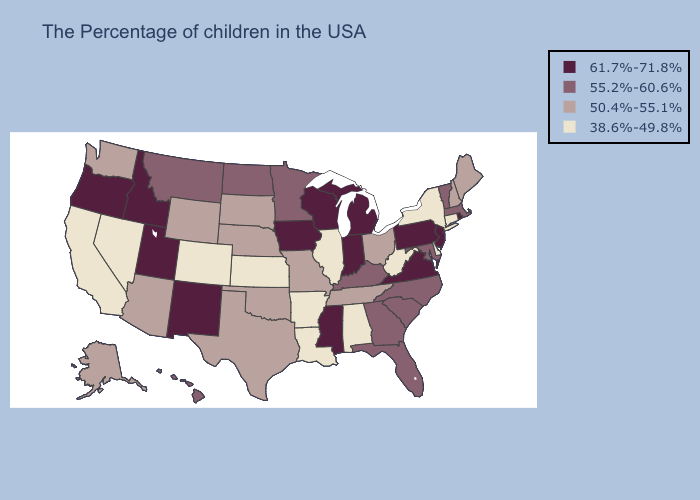Does the first symbol in the legend represent the smallest category?
Be succinct. No. Does the map have missing data?
Answer briefly. No. Which states have the highest value in the USA?
Keep it brief. Rhode Island, New Jersey, Pennsylvania, Virginia, Michigan, Indiana, Wisconsin, Mississippi, Iowa, New Mexico, Utah, Idaho, Oregon. Does New Hampshire have the highest value in the Northeast?
Write a very short answer. No. Does Virginia have the lowest value in the USA?
Short answer required. No. Does Delaware have the lowest value in the USA?
Be succinct. Yes. What is the value of Nevada?
Write a very short answer. 38.6%-49.8%. Does the first symbol in the legend represent the smallest category?
Give a very brief answer. No. Which states hav the highest value in the Northeast?
Answer briefly. Rhode Island, New Jersey, Pennsylvania. Which states have the highest value in the USA?
Short answer required. Rhode Island, New Jersey, Pennsylvania, Virginia, Michigan, Indiana, Wisconsin, Mississippi, Iowa, New Mexico, Utah, Idaho, Oregon. Which states have the lowest value in the USA?
Be succinct. Connecticut, New York, Delaware, West Virginia, Alabama, Illinois, Louisiana, Arkansas, Kansas, Colorado, Nevada, California. Name the states that have a value in the range 38.6%-49.8%?
Write a very short answer. Connecticut, New York, Delaware, West Virginia, Alabama, Illinois, Louisiana, Arkansas, Kansas, Colorado, Nevada, California. Which states hav the highest value in the West?
Answer briefly. New Mexico, Utah, Idaho, Oregon. What is the value of Wisconsin?
Keep it brief. 61.7%-71.8%. What is the lowest value in states that border Rhode Island?
Write a very short answer. 38.6%-49.8%. 